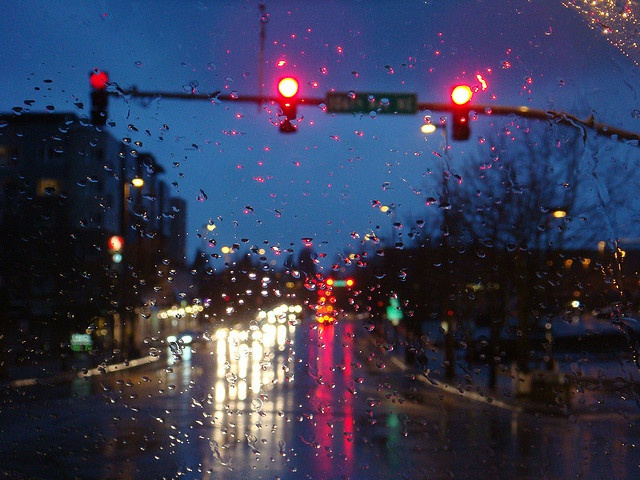Describe the objects in this image and their specific colors. I can see traffic light in darkblue, white, maroon, brown, and black tones, traffic light in darkblue, black, navy, red, and blue tones, traffic light in darkblue, black, maroon, khaki, and brown tones, traffic light in darkblue, white, red, magenta, and salmon tones, and traffic light in darkblue, maroon, brown, red, and purple tones in this image. 